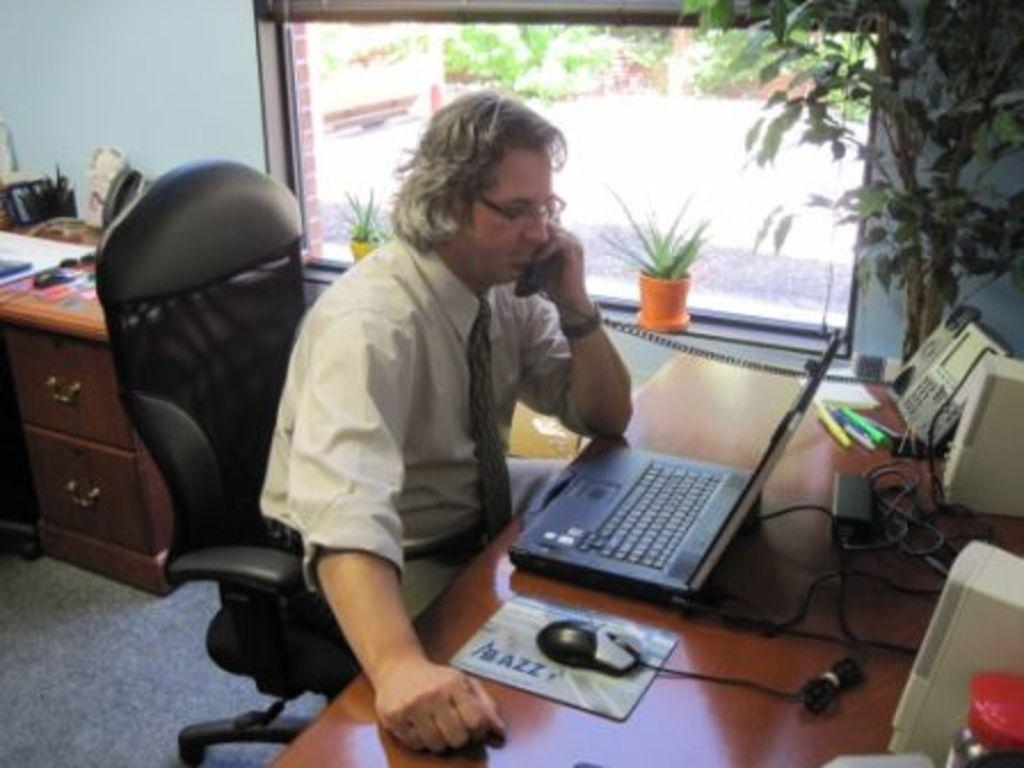What is the person in the image doing? The person is sitting on a chair and using a laptop. What else is the person using in the image? The person is also using a phone. What can be seen in the background of the image? There is a tree visible in the background. What object is present on the table or surface in the image? There is a glass in the scene. What type of furniture is visible in the background? There are drawers in the background. What type of cheese is being traded between the ant and the person in the image? There are no ants or cheese present in the image. The person is using a laptop and a phone, and there is a tree, a glass, and drawers visible in the background. 